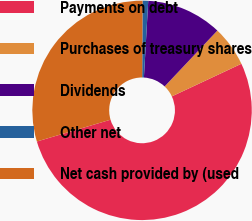<chart> <loc_0><loc_0><loc_500><loc_500><pie_chart><fcel>Payments on debt<fcel>Purchases of treasury shares<fcel>Dividends<fcel>Other net<fcel>Net cash provided by (used<nl><fcel>52.4%<fcel>5.98%<fcel>11.14%<fcel>0.83%<fcel>29.65%<nl></chart> 